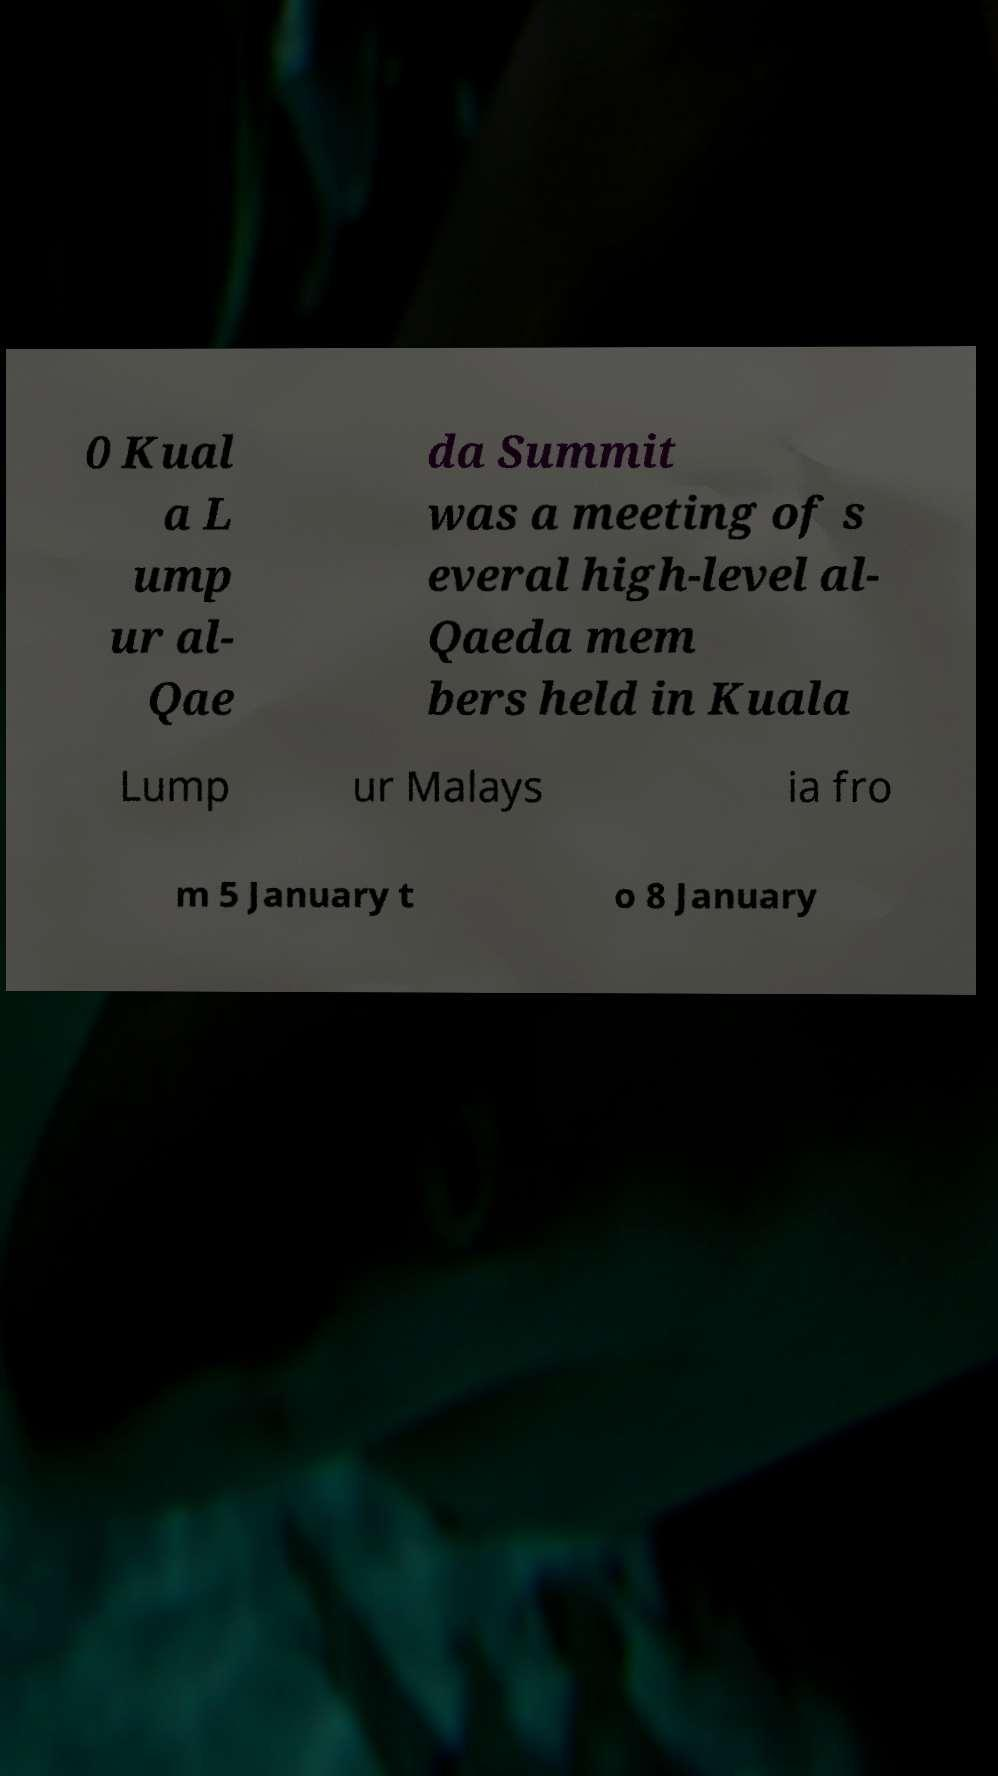Can you accurately transcribe the text from the provided image for me? 0 Kual a L ump ur al- Qae da Summit was a meeting of s everal high-level al- Qaeda mem bers held in Kuala Lump ur Malays ia fro m 5 January t o 8 January 